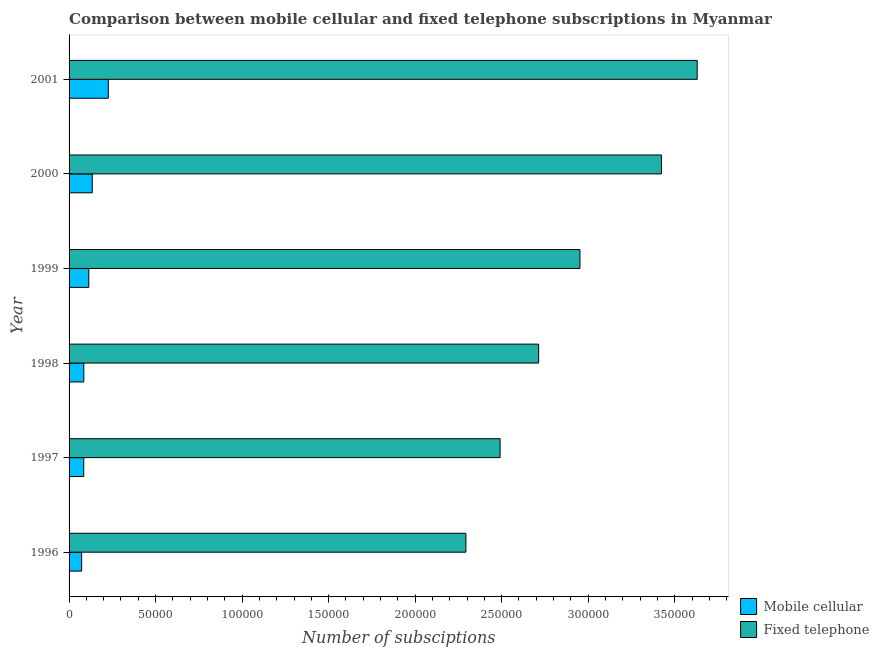How many different coloured bars are there?
Provide a short and direct response. 2. How many groups of bars are there?
Your answer should be compact. 6. Are the number of bars on each tick of the Y-axis equal?
Your answer should be compact. Yes. How many bars are there on the 4th tick from the top?
Make the answer very short. 2. How many bars are there on the 2nd tick from the bottom?
Ensure brevity in your answer.  2. In how many cases, is the number of bars for a given year not equal to the number of legend labels?
Your answer should be compact. 0. What is the number of mobile cellular subscriptions in 1998?
Provide a succinct answer. 8516. Across all years, what is the maximum number of fixed telephone subscriptions?
Your answer should be very brief. 3.63e+05. Across all years, what is the minimum number of mobile cellular subscriptions?
Ensure brevity in your answer.  7260. In which year was the number of mobile cellular subscriptions minimum?
Offer a very short reply. 1996. What is the total number of fixed telephone subscriptions in the graph?
Offer a terse response. 1.75e+06. What is the difference between the number of fixed telephone subscriptions in 1999 and that in 2001?
Keep it short and to the point. -6.77e+04. What is the difference between the number of fixed telephone subscriptions in 2000 and the number of mobile cellular subscriptions in 1996?
Provide a short and direct response. 3.35e+05. What is the average number of fixed telephone subscriptions per year?
Provide a succinct answer. 2.92e+05. In the year 2000, what is the difference between the number of fixed telephone subscriptions and number of mobile cellular subscriptions?
Give a very brief answer. 3.29e+05. In how many years, is the number of mobile cellular subscriptions greater than 170000 ?
Your response must be concise. 0. What is the ratio of the number of mobile cellular subscriptions in 1996 to that in 1998?
Provide a succinct answer. 0.85. What is the difference between the highest and the second highest number of fixed telephone subscriptions?
Provide a short and direct response. 2.07e+04. What is the difference between the highest and the lowest number of fixed telephone subscriptions?
Keep it short and to the point. 1.34e+05. Is the sum of the number of fixed telephone subscriptions in 1996 and 1998 greater than the maximum number of mobile cellular subscriptions across all years?
Offer a very short reply. Yes. What does the 2nd bar from the top in 1996 represents?
Keep it short and to the point. Mobile cellular. What does the 2nd bar from the bottom in 1997 represents?
Offer a terse response. Fixed telephone. How many bars are there?
Give a very brief answer. 12. Are all the bars in the graph horizontal?
Your answer should be compact. Yes. How many years are there in the graph?
Make the answer very short. 6. What is the difference between two consecutive major ticks on the X-axis?
Offer a terse response. 5.00e+04. Are the values on the major ticks of X-axis written in scientific E-notation?
Give a very brief answer. No. Does the graph contain grids?
Provide a succinct answer. No. Where does the legend appear in the graph?
Make the answer very short. Bottom right. What is the title of the graph?
Offer a terse response. Comparison between mobile cellular and fixed telephone subscriptions in Myanmar. Does "Largest city" appear as one of the legend labels in the graph?
Keep it short and to the point. No. What is the label or title of the X-axis?
Offer a terse response. Number of subsciptions. What is the Number of subsciptions in Mobile cellular in 1996?
Provide a short and direct response. 7260. What is the Number of subsciptions of Fixed telephone in 1996?
Your answer should be compact. 2.29e+05. What is the Number of subsciptions of Mobile cellular in 1997?
Your answer should be very brief. 8492. What is the Number of subsciptions in Fixed telephone in 1997?
Provide a succinct answer. 2.49e+05. What is the Number of subsciptions in Mobile cellular in 1998?
Ensure brevity in your answer.  8516. What is the Number of subsciptions in Fixed telephone in 1998?
Ensure brevity in your answer.  2.71e+05. What is the Number of subsciptions in Mobile cellular in 1999?
Your answer should be compact. 1.14e+04. What is the Number of subsciptions of Fixed telephone in 1999?
Your response must be concise. 2.95e+05. What is the Number of subsciptions in Mobile cellular in 2000?
Ensure brevity in your answer.  1.34e+04. What is the Number of subsciptions of Fixed telephone in 2000?
Give a very brief answer. 3.42e+05. What is the Number of subsciptions in Mobile cellular in 2001?
Offer a terse response. 2.27e+04. What is the Number of subsciptions of Fixed telephone in 2001?
Offer a terse response. 3.63e+05. Across all years, what is the maximum Number of subsciptions of Mobile cellular?
Provide a short and direct response. 2.27e+04. Across all years, what is the maximum Number of subsciptions of Fixed telephone?
Your answer should be very brief. 3.63e+05. Across all years, what is the minimum Number of subsciptions in Mobile cellular?
Give a very brief answer. 7260. Across all years, what is the minimum Number of subsciptions in Fixed telephone?
Provide a short and direct response. 2.29e+05. What is the total Number of subsciptions in Mobile cellular in the graph?
Your answer should be very brief. 7.17e+04. What is the total Number of subsciptions in Fixed telephone in the graph?
Your response must be concise. 1.75e+06. What is the difference between the Number of subsciptions in Mobile cellular in 1996 and that in 1997?
Provide a short and direct response. -1232. What is the difference between the Number of subsciptions in Fixed telephone in 1996 and that in 1997?
Ensure brevity in your answer.  -1.98e+04. What is the difference between the Number of subsciptions of Mobile cellular in 1996 and that in 1998?
Keep it short and to the point. -1256. What is the difference between the Number of subsciptions of Fixed telephone in 1996 and that in 1998?
Offer a terse response. -4.20e+04. What is the difference between the Number of subsciptions in Mobile cellular in 1996 and that in 1999?
Your answer should be compact. -4129. What is the difference between the Number of subsciptions of Fixed telephone in 1996 and that in 1999?
Keep it short and to the point. -6.59e+04. What is the difference between the Number of subsciptions of Mobile cellular in 1996 and that in 2000?
Offer a terse response. -6137. What is the difference between the Number of subsciptions in Fixed telephone in 1996 and that in 2000?
Your response must be concise. -1.13e+05. What is the difference between the Number of subsciptions of Mobile cellular in 1996 and that in 2001?
Give a very brief answer. -1.54e+04. What is the difference between the Number of subsciptions in Fixed telephone in 1996 and that in 2001?
Ensure brevity in your answer.  -1.34e+05. What is the difference between the Number of subsciptions in Mobile cellular in 1997 and that in 1998?
Provide a succinct answer. -24. What is the difference between the Number of subsciptions in Fixed telephone in 1997 and that in 1998?
Ensure brevity in your answer.  -2.23e+04. What is the difference between the Number of subsciptions of Mobile cellular in 1997 and that in 1999?
Offer a terse response. -2897. What is the difference between the Number of subsciptions in Fixed telephone in 1997 and that in 1999?
Make the answer very short. -4.62e+04. What is the difference between the Number of subsciptions in Mobile cellular in 1997 and that in 2000?
Offer a very short reply. -4905. What is the difference between the Number of subsciptions in Fixed telephone in 1997 and that in 2000?
Ensure brevity in your answer.  -9.32e+04. What is the difference between the Number of subsciptions of Mobile cellular in 1997 and that in 2001?
Provide a short and direct response. -1.42e+04. What is the difference between the Number of subsciptions in Fixed telephone in 1997 and that in 2001?
Provide a short and direct response. -1.14e+05. What is the difference between the Number of subsciptions of Mobile cellular in 1998 and that in 1999?
Offer a terse response. -2873. What is the difference between the Number of subsciptions of Fixed telephone in 1998 and that in 1999?
Keep it short and to the point. -2.39e+04. What is the difference between the Number of subsciptions of Mobile cellular in 1998 and that in 2000?
Offer a terse response. -4881. What is the difference between the Number of subsciptions of Fixed telephone in 1998 and that in 2000?
Make the answer very short. -7.10e+04. What is the difference between the Number of subsciptions in Mobile cellular in 1998 and that in 2001?
Ensure brevity in your answer.  -1.42e+04. What is the difference between the Number of subsciptions of Fixed telephone in 1998 and that in 2001?
Your response must be concise. -9.16e+04. What is the difference between the Number of subsciptions of Mobile cellular in 1999 and that in 2000?
Offer a terse response. -2008. What is the difference between the Number of subsciptions of Fixed telephone in 1999 and that in 2000?
Keep it short and to the point. -4.71e+04. What is the difference between the Number of subsciptions of Mobile cellular in 1999 and that in 2001?
Keep it short and to the point. -1.13e+04. What is the difference between the Number of subsciptions in Fixed telephone in 1999 and that in 2001?
Make the answer very short. -6.77e+04. What is the difference between the Number of subsciptions of Mobile cellular in 2000 and that in 2001?
Your answer should be very brief. -9274. What is the difference between the Number of subsciptions of Fixed telephone in 2000 and that in 2001?
Make the answer very short. -2.07e+04. What is the difference between the Number of subsciptions in Mobile cellular in 1996 and the Number of subsciptions in Fixed telephone in 1997?
Offer a very short reply. -2.42e+05. What is the difference between the Number of subsciptions of Mobile cellular in 1996 and the Number of subsciptions of Fixed telephone in 1998?
Your answer should be very brief. -2.64e+05. What is the difference between the Number of subsciptions of Mobile cellular in 1996 and the Number of subsciptions of Fixed telephone in 1999?
Make the answer very short. -2.88e+05. What is the difference between the Number of subsciptions of Mobile cellular in 1996 and the Number of subsciptions of Fixed telephone in 2000?
Provide a short and direct response. -3.35e+05. What is the difference between the Number of subsciptions of Mobile cellular in 1996 and the Number of subsciptions of Fixed telephone in 2001?
Offer a very short reply. -3.56e+05. What is the difference between the Number of subsciptions of Mobile cellular in 1997 and the Number of subsciptions of Fixed telephone in 1998?
Your response must be concise. -2.63e+05. What is the difference between the Number of subsciptions of Mobile cellular in 1997 and the Number of subsciptions of Fixed telephone in 1999?
Offer a very short reply. -2.87e+05. What is the difference between the Number of subsciptions in Mobile cellular in 1997 and the Number of subsciptions in Fixed telephone in 2000?
Provide a short and direct response. -3.34e+05. What is the difference between the Number of subsciptions of Mobile cellular in 1997 and the Number of subsciptions of Fixed telephone in 2001?
Provide a short and direct response. -3.54e+05. What is the difference between the Number of subsciptions of Mobile cellular in 1998 and the Number of subsciptions of Fixed telephone in 1999?
Provide a succinct answer. -2.87e+05. What is the difference between the Number of subsciptions in Mobile cellular in 1998 and the Number of subsciptions in Fixed telephone in 2000?
Offer a very short reply. -3.34e+05. What is the difference between the Number of subsciptions of Mobile cellular in 1998 and the Number of subsciptions of Fixed telephone in 2001?
Your answer should be compact. -3.54e+05. What is the difference between the Number of subsciptions in Mobile cellular in 1999 and the Number of subsciptions in Fixed telephone in 2000?
Give a very brief answer. -3.31e+05. What is the difference between the Number of subsciptions in Mobile cellular in 1999 and the Number of subsciptions in Fixed telephone in 2001?
Provide a short and direct response. -3.52e+05. What is the difference between the Number of subsciptions of Mobile cellular in 2000 and the Number of subsciptions of Fixed telephone in 2001?
Provide a short and direct response. -3.50e+05. What is the average Number of subsciptions of Mobile cellular per year?
Ensure brevity in your answer.  1.20e+04. What is the average Number of subsciptions in Fixed telephone per year?
Your answer should be compact. 2.92e+05. In the year 1996, what is the difference between the Number of subsciptions of Mobile cellular and Number of subsciptions of Fixed telephone?
Make the answer very short. -2.22e+05. In the year 1997, what is the difference between the Number of subsciptions in Mobile cellular and Number of subsciptions in Fixed telephone?
Provide a short and direct response. -2.41e+05. In the year 1998, what is the difference between the Number of subsciptions in Mobile cellular and Number of subsciptions in Fixed telephone?
Keep it short and to the point. -2.63e+05. In the year 1999, what is the difference between the Number of subsciptions in Mobile cellular and Number of subsciptions in Fixed telephone?
Make the answer very short. -2.84e+05. In the year 2000, what is the difference between the Number of subsciptions of Mobile cellular and Number of subsciptions of Fixed telephone?
Your response must be concise. -3.29e+05. In the year 2001, what is the difference between the Number of subsciptions of Mobile cellular and Number of subsciptions of Fixed telephone?
Offer a terse response. -3.40e+05. What is the ratio of the Number of subsciptions in Mobile cellular in 1996 to that in 1997?
Your response must be concise. 0.85. What is the ratio of the Number of subsciptions of Fixed telephone in 1996 to that in 1997?
Provide a short and direct response. 0.92. What is the ratio of the Number of subsciptions in Mobile cellular in 1996 to that in 1998?
Offer a terse response. 0.85. What is the ratio of the Number of subsciptions in Fixed telephone in 1996 to that in 1998?
Make the answer very short. 0.85. What is the ratio of the Number of subsciptions of Mobile cellular in 1996 to that in 1999?
Your response must be concise. 0.64. What is the ratio of the Number of subsciptions in Fixed telephone in 1996 to that in 1999?
Provide a succinct answer. 0.78. What is the ratio of the Number of subsciptions in Mobile cellular in 1996 to that in 2000?
Your answer should be compact. 0.54. What is the ratio of the Number of subsciptions in Fixed telephone in 1996 to that in 2000?
Provide a succinct answer. 0.67. What is the ratio of the Number of subsciptions of Mobile cellular in 1996 to that in 2001?
Make the answer very short. 0.32. What is the ratio of the Number of subsciptions of Fixed telephone in 1996 to that in 2001?
Keep it short and to the point. 0.63. What is the ratio of the Number of subsciptions in Fixed telephone in 1997 to that in 1998?
Offer a very short reply. 0.92. What is the ratio of the Number of subsciptions in Mobile cellular in 1997 to that in 1999?
Provide a short and direct response. 0.75. What is the ratio of the Number of subsciptions of Fixed telephone in 1997 to that in 1999?
Offer a very short reply. 0.84. What is the ratio of the Number of subsciptions of Mobile cellular in 1997 to that in 2000?
Ensure brevity in your answer.  0.63. What is the ratio of the Number of subsciptions of Fixed telephone in 1997 to that in 2000?
Provide a short and direct response. 0.73. What is the ratio of the Number of subsciptions in Mobile cellular in 1997 to that in 2001?
Your answer should be compact. 0.37. What is the ratio of the Number of subsciptions in Fixed telephone in 1997 to that in 2001?
Provide a succinct answer. 0.69. What is the ratio of the Number of subsciptions in Mobile cellular in 1998 to that in 1999?
Ensure brevity in your answer.  0.75. What is the ratio of the Number of subsciptions in Fixed telephone in 1998 to that in 1999?
Your answer should be compact. 0.92. What is the ratio of the Number of subsciptions of Mobile cellular in 1998 to that in 2000?
Provide a succinct answer. 0.64. What is the ratio of the Number of subsciptions of Fixed telephone in 1998 to that in 2000?
Ensure brevity in your answer.  0.79. What is the ratio of the Number of subsciptions of Mobile cellular in 1998 to that in 2001?
Provide a succinct answer. 0.38. What is the ratio of the Number of subsciptions of Fixed telephone in 1998 to that in 2001?
Keep it short and to the point. 0.75. What is the ratio of the Number of subsciptions of Mobile cellular in 1999 to that in 2000?
Ensure brevity in your answer.  0.85. What is the ratio of the Number of subsciptions of Fixed telephone in 1999 to that in 2000?
Offer a terse response. 0.86. What is the ratio of the Number of subsciptions in Mobile cellular in 1999 to that in 2001?
Provide a succinct answer. 0.5. What is the ratio of the Number of subsciptions of Fixed telephone in 1999 to that in 2001?
Offer a terse response. 0.81. What is the ratio of the Number of subsciptions in Mobile cellular in 2000 to that in 2001?
Provide a short and direct response. 0.59. What is the ratio of the Number of subsciptions in Fixed telephone in 2000 to that in 2001?
Your answer should be very brief. 0.94. What is the difference between the highest and the second highest Number of subsciptions of Mobile cellular?
Give a very brief answer. 9274. What is the difference between the highest and the second highest Number of subsciptions of Fixed telephone?
Offer a terse response. 2.07e+04. What is the difference between the highest and the lowest Number of subsciptions of Mobile cellular?
Give a very brief answer. 1.54e+04. What is the difference between the highest and the lowest Number of subsciptions in Fixed telephone?
Ensure brevity in your answer.  1.34e+05. 